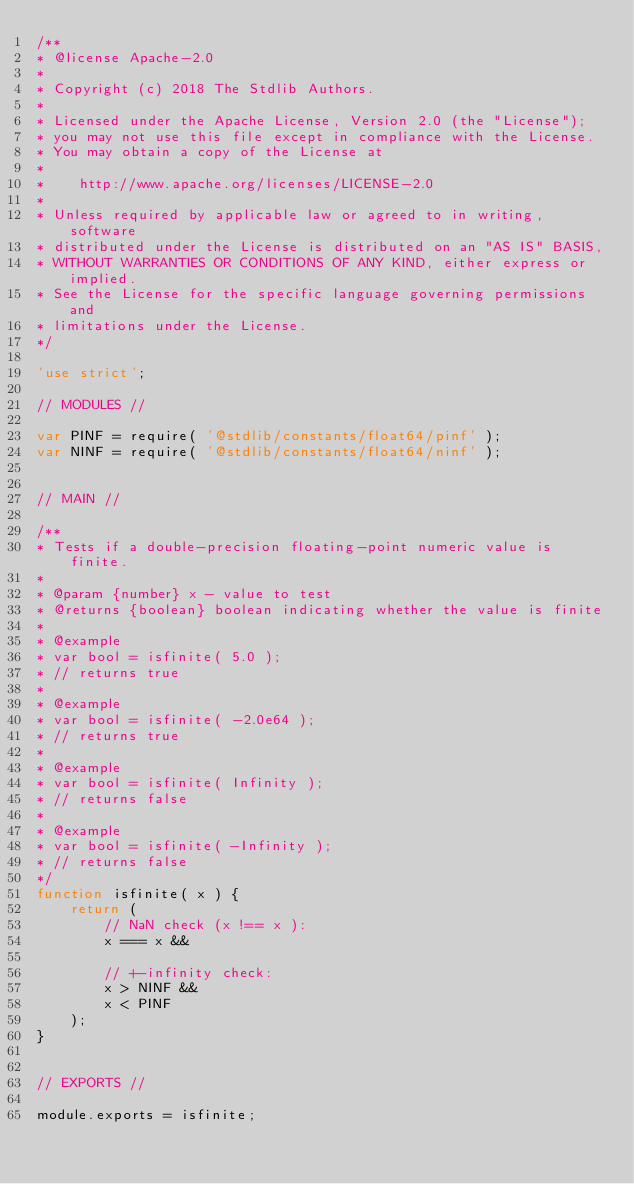Convert code to text. <code><loc_0><loc_0><loc_500><loc_500><_JavaScript_>/**
* @license Apache-2.0
*
* Copyright (c) 2018 The Stdlib Authors.
*
* Licensed under the Apache License, Version 2.0 (the "License");
* you may not use this file except in compliance with the License.
* You may obtain a copy of the License at
*
*    http://www.apache.org/licenses/LICENSE-2.0
*
* Unless required by applicable law or agreed to in writing, software
* distributed under the License is distributed on an "AS IS" BASIS,
* WITHOUT WARRANTIES OR CONDITIONS OF ANY KIND, either express or implied.
* See the License for the specific language governing permissions and
* limitations under the License.
*/

'use strict';

// MODULES //

var PINF = require( '@stdlib/constants/float64/pinf' );
var NINF = require( '@stdlib/constants/float64/ninf' );


// MAIN //

/**
* Tests if a double-precision floating-point numeric value is finite.
*
* @param {number} x - value to test
* @returns {boolean} boolean indicating whether the value is finite
*
* @example
* var bool = isfinite( 5.0 );
* // returns true
*
* @example
* var bool = isfinite( -2.0e64 );
* // returns true
*
* @example
* var bool = isfinite( Infinity );
* // returns false
*
* @example
* var bool = isfinite( -Infinity );
* // returns false
*/
function isfinite( x ) {
	return (
		// NaN check (x !== x ):
		x === x &&

		// +-infinity check:
		x > NINF &&
		x < PINF
	);
}


// EXPORTS //

module.exports = isfinite;
</code> 